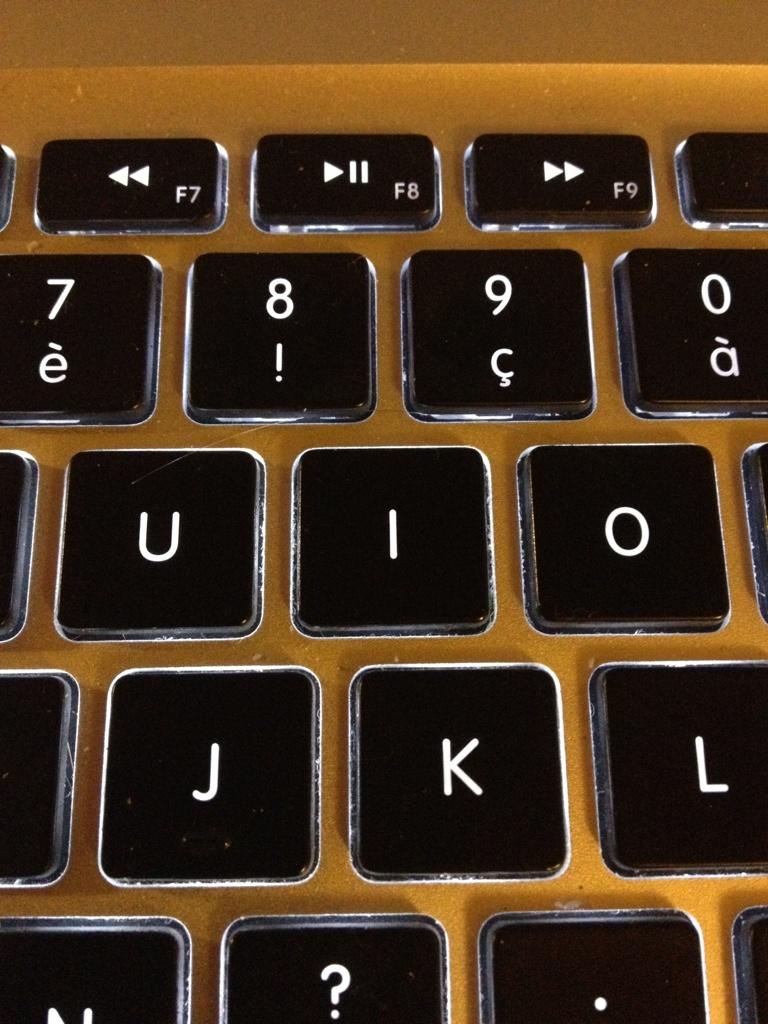What f key also functions as the play/pause key?
Make the answer very short. F8. 